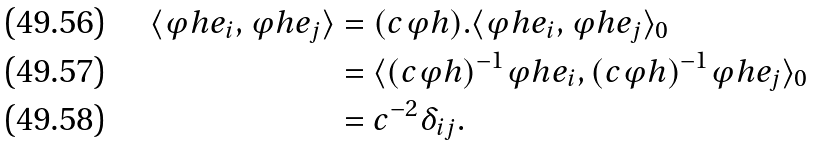<formula> <loc_0><loc_0><loc_500><loc_500>\langle \varphi h e _ { i } , \varphi h e _ { j } \rangle & = ( c \varphi h ) . \langle \varphi h e _ { i } , \varphi h e _ { j } \rangle _ { 0 } \\ & = \langle ( c \varphi h ) ^ { - 1 } \varphi h e _ { i } , ( c \varphi h ) ^ { - 1 } \varphi h e _ { j } \rangle _ { 0 } \\ & = c ^ { - 2 } \delta _ { i j } .</formula> 